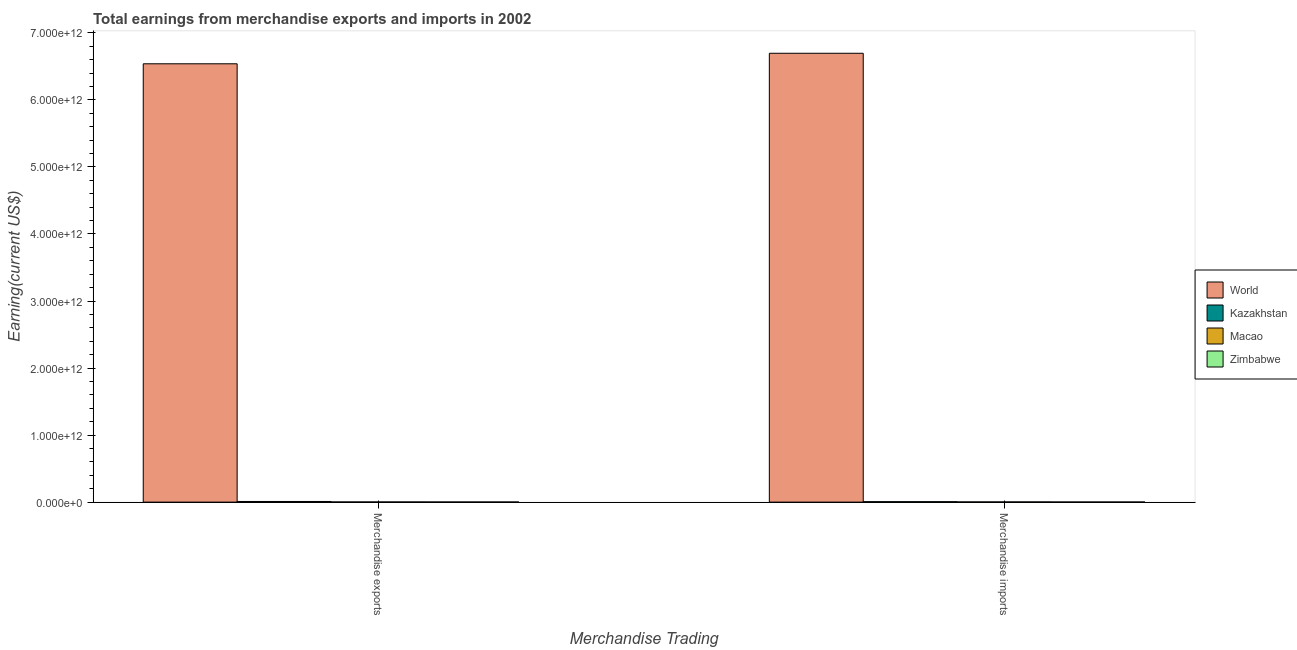How many groups of bars are there?
Offer a very short reply. 2. Are the number of bars per tick equal to the number of legend labels?
Provide a short and direct response. Yes. How many bars are there on the 1st tick from the left?
Provide a succinct answer. 4. What is the label of the 1st group of bars from the left?
Provide a succinct answer. Merchandise exports. What is the earnings from merchandise imports in Kazakhstan?
Offer a very short reply. 6.58e+09. Across all countries, what is the maximum earnings from merchandise exports?
Provide a succinct answer. 6.54e+12. Across all countries, what is the minimum earnings from merchandise exports?
Make the answer very short. 2.01e+09. In which country was the earnings from merchandise exports maximum?
Provide a succinct answer. World. In which country was the earnings from merchandise exports minimum?
Make the answer very short. Zimbabwe. What is the total earnings from merchandise exports in the graph?
Your answer should be very brief. 6.55e+12. What is the difference between the earnings from merchandise imports in Zimbabwe and that in Macao?
Provide a short and direct response. -1.26e+09. What is the difference between the earnings from merchandise imports in Zimbabwe and the earnings from merchandise exports in Macao?
Keep it short and to the point. -6.05e+08. What is the average earnings from merchandise exports per country?
Provide a short and direct response. 1.64e+12. What is the difference between the earnings from merchandise imports and earnings from merchandise exports in Macao?
Your response must be concise. 6.53e+08. In how many countries, is the earnings from merchandise imports greater than 4400000000000 US$?
Make the answer very short. 1. What is the ratio of the earnings from merchandise imports in Macao to that in Zimbabwe?
Your answer should be compact. 1.72. What does the 1st bar from the left in Merchandise exports represents?
Keep it short and to the point. World. What does the 1st bar from the right in Merchandise imports represents?
Give a very brief answer. Zimbabwe. How many bars are there?
Make the answer very short. 8. Are all the bars in the graph horizontal?
Ensure brevity in your answer.  No. What is the difference between two consecutive major ticks on the Y-axis?
Ensure brevity in your answer.  1.00e+12. Are the values on the major ticks of Y-axis written in scientific E-notation?
Provide a succinct answer. Yes. Does the graph contain any zero values?
Keep it short and to the point. No. Does the graph contain grids?
Provide a short and direct response. No. Where does the legend appear in the graph?
Make the answer very short. Center right. How many legend labels are there?
Your answer should be very brief. 4. How are the legend labels stacked?
Offer a very short reply. Vertical. What is the title of the graph?
Ensure brevity in your answer.  Total earnings from merchandise exports and imports in 2002. Does "Benin" appear as one of the legend labels in the graph?
Keep it short and to the point. No. What is the label or title of the X-axis?
Your answer should be very brief. Merchandise Trading. What is the label or title of the Y-axis?
Your answer should be compact. Earning(current US$). What is the Earning(current US$) in World in Merchandise exports?
Provide a short and direct response. 6.54e+12. What is the Earning(current US$) of Kazakhstan in Merchandise exports?
Your answer should be very brief. 9.67e+09. What is the Earning(current US$) in Macao in Merchandise exports?
Offer a very short reply. 2.36e+09. What is the Earning(current US$) in Zimbabwe in Merchandise exports?
Your response must be concise. 2.01e+09. What is the Earning(current US$) in World in Merchandise imports?
Make the answer very short. 6.70e+12. What is the Earning(current US$) of Kazakhstan in Merchandise imports?
Your answer should be compact. 6.58e+09. What is the Earning(current US$) of Macao in Merchandise imports?
Offer a very short reply. 3.01e+09. What is the Earning(current US$) of Zimbabwe in Merchandise imports?
Your response must be concise. 1.75e+09. Across all Merchandise Trading, what is the maximum Earning(current US$) of World?
Offer a terse response. 6.70e+12. Across all Merchandise Trading, what is the maximum Earning(current US$) in Kazakhstan?
Offer a very short reply. 9.67e+09. Across all Merchandise Trading, what is the maximum Earning(current US$) of Macao?
Your response must be concise. 3.01e+09. Across all Merchandise Trading, what is the maximum Earning(current US$) of Zimbabwe?
Offer a very short reply. 2.01e+09. Across all Merchandise Trading, what is the minimum Earning(current US$) of World?
Keep it short and to the point. 6.54e+12. Across all Merchandise Trading, what is the minimum Earning(current US$) of Kazakhstan?
Provide a succinct answer. 6.58e+09. Across all Merchandise Trading, what is the minimum Earning(current US$) of Macao?
Offer a very short reply. 2.36e+09. Across all Merchandise Trading, what is the minimum Earning(current US$) of Zimbabwe?
Provide a short and direct response. 1.75e+09. What is the total Earning(current US$) in World in the graph?
Ensure brevity in your answer.  1.32e+13. What is the total Earning(current US$) in Kazakhstan in the graph?
Your answer should be compact. 1.63e+1. What is the total Earning(current US$) of Macao in the graph?
Provide a succinct answer. 5.37e+09. What is the total Earning(current US$) in Zimbabwe in the graph?
Ensure brevity in your answer.  3.76e+09. What is the difference between the Earning(current US$) of World in Merchandise exports and that in Merchandise imports?
Provide a succinct answer. -1.57e+11. What is the difference between the Earning(current US$) of Kazakhstan in Merchandise exports and that in Merchandise imports?
Make the answer very short. 3.09e+09. What is the difference between the Earning(current US$) of Macao in Merchandise exports and that in Merchandise imports?
Offer a very short reply. -6.53e+08. What is the difference between the Earning(current US$) of Zimbabwe in Merchandise exports and that in Merchandise imports?
Ensure brevity in your answer.  2.61e+08. What is the difference between the Earning(current US$) of World in Merchandise exports and the Earning(current US$) of Kazakhstan in Merchandise imports?
Provide a short and direct response. 6.53e+12. What is the difference between the Earning(current US$) of World in Merchandise exports and the Earning(current US$) of Macao in Merchandise imports?
Provide a succinct answer. 6.54e+12. What is the difference between the Earning(current US$) in World in Merchandise exports and the Earning(current US$) in Zimbabwe in Merchandise imports?
Offer a terse response. 6.54e+12. What is the difference between the Earning(current US$) of Kazakhstan in Merchandise exports and the Earning(current US$) of Macao in Merchandise imports?
Your response must be concise. 6.66e+09. What is the difference between the Earning(current US$) of Kazakhstan in Merchandise exports and the Earning(current US$) of Zimbabwe in Merchandise imports?
Keep it short and to the point. 7.92e+09. What is the difference between the Earning(current US$) of Macao in Merchandise exports and the Earning(current US$) of Zimbabwe in Merchandise imports?
Your answer should be compact. 6.05e+08. What is the average Earning(current US$) of World per Merchandise Trading?
Provide a short and direct response. 6.62e+12. What is the average Earning(current US$) of Kazakhstan per Merchandise Trading?
Your answer should be compact. 8.13e+09. What is the average Earning(current US$) of Macao per Merchandise Trading?
Offer a terse response. 2.68e+09. What is the average Earning(current US$) of Zimbabwe per Merchandise Trading?
Provide a succinct answer. 1.88e+09. What is the difference between the Earning(current US$) in World and Earning(current US$) in Kazakhstan in Merchandise exports?
Your answer should be compact. 6.53e+12. What is the difference between the Earning(current US$) in World and Earning(current US$) in Macao in Merchandise exports?
Your response must be concise. 6.54e+12. What is the difference between the Earning(current US$) of World and Earning(current US$) of Zimbabwe in Merchandise exports?
Give a very brief answer. 6.54e+12. What is the difference between the Earning(current US$) in Kazakhstan and Earning(current US$) in Macao in Merchandise exports?
Offer a terse response. 7.31e+09. What is the difference between the Earning(current US$) in Kazakhstan and Earning(current US$) in Zimbabwe in Merchandise exports?
Keep it short and to the point. 7.66e+09. What is the difference between the Earning(current US$) of Macao and Earning(current US$) of Zimbabwe in Merchandise exports?
Your answer should be compact. 3.44e+08. What is the difference between the Earning(current US$) in World and Earning(current US$) in Kazakhstan in Merchandise imports?
Your answer should be compact. 6.69e+12. What is the difference between the Earning(current US$) in World and Earning(current US$) in Macao in Merchandise imports?
Provide a short and direct response. 6.69e+12. What is the difference between the Earning(current US$) of World and Earning(current US$) of Zimbabwe in Merchandise imports?
Make the answer very short. 6.69e+12. What is the difference between the Earning(current US$) in Kazakhstan and Earning(current US$) in Macao in Merchandise imports?
Give a very brief answer. 3.57e+09. What is the difference between the Earning(current US$) in Kazakhstan and Earning(current US$) in Zimbabwe in Merchandise imports?
Your answer should be compact. 4.83e+09. What is the difference between the Earning(current US$) in Macao and Earning(current US$) in Zimbabwe in Merchandise imports?
Keep it short and to the point. 1.26e+09. What is the ratio of the Earning(current US$) in World in Merchandise exports to that in Merchandise imports?
Provide a short and direct response. 0.98. What is the ratio of the Earning(current US$) in Kazakhstan in Merchandise exports to that in Merchandise imports?
Your answer should be compact. 1.47. What is the ratio of the Earning(current US$) of Macao in Merchandise exports to that in Merchandise imports?
Make the answer very short. 0.78. What is the ratio of the Earning(current US$) in Zimbabwe in Merchandise exports to that in Merchandise imports?
Give a very brief answer. 1.15. What is the difference between the highest and the second highest Earning(current US$) of World?
Give a very brief answer. 1.57e+11. What is the difference between the highest and the second highest Earning(current US$) of Kazakhstan?
Offer a very short reply. 3.09e+09. What is the difference between the highest and the second highest Earning(current US$) of Macao?
Your answer should be very brief. 6.53e+08. What is the difference between the highest and the second highest Earning(current US$) in Zimbabwe?
Your answer should be compact. 2.61e+08. What is the difference between the highest and the lowest Earning(current US$) of World?
Your answer should be very brief. 1.57e+11. What is the difference between the highest and the lowest Earning(current US$) in Kazakhstan?
Make the answer very short. 3.09e+09. What is the difference between the highest and the lowest Earning(current US$) of Macao?
Your response must be concise. 6.53e+08. What is the difference between the highest and the lowest Earning(current US$) in Zimbabwe?
Your response must be concise. 2.61e+08. 